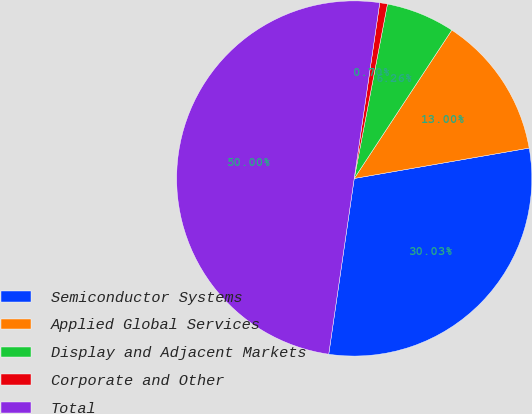Convert chart to OTSL. <chart><loc_0><loc_0><loc_500><loc_500><pie_chart><fcel>Semiconductor Systems<fcel>Applied Global Services<fcel>Display and Adjacent Markets<fcel>Corporate and Other<fcel>Total<nl><fcel>30.03%<fcel>13.0%<fcel>6.26%<fcel>0.7%<fcel>50.0%<nl></chart> 